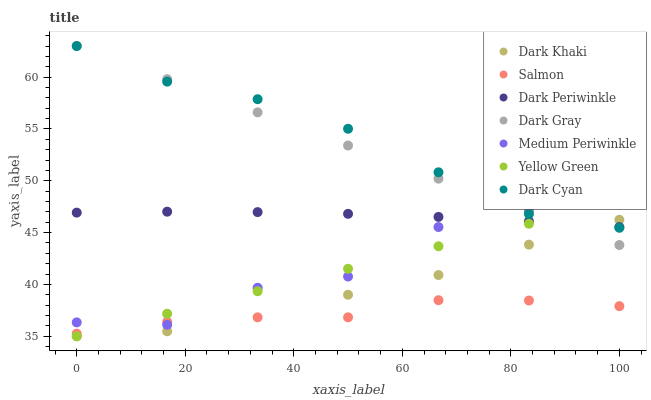Does Salmon have the minimum area under the curve?
Answer yes or no. Yes. Does Dark Cyan have the maximum area under the curve?
Answer yes or no. Yes. Does Yellow Green have the minimum area under the curve?
Answer yes or no. No. Does Yellow Green have the maximum area under the curve?
Answer yes or no. No. Is Yellow Green the smoothest?
Answer yes or no. Yes. Is Medium Periwinkle the roughest?
Answer yes or no. Yes. Is Medium Periwinkle the smoothest?
Answer yes or no. No. Is Yellow Green the roughest?
Answer yes or no. No. Does Yellow Green have the lowest value?
Answer yes or no. Yes. Does Medium Periwinkle have the lowest value?
Answer yes or no. No. Does Dark Cyan have the highest value?
Answer yes or no. Yes. Does Yellow Green have the highest value?
Answer yes or no. No. Is Dark Khaki less than Medium Periwinkle?
Answer yes or no. Yes. Is Dark Cyan greater than Salmon?
Answer yes or no. Yes. Does Dark Khaki intersect Dark Cyan?
Answer yes or no. Yes. Is Dark Khaki less than Dark Cyan?
Answer yes or no. No. Is Dark Khaki greater than Dark Cyan?
Answer yes or no. No. Does Dark Khaki intersect Medium Periwinkle?
Answer yes or no. No. 